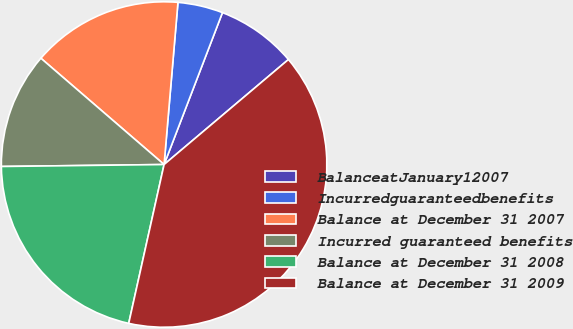Convert chart. <chart><loc_0><loc_0><loc_500><loc_500><pie_chart><fcel>BalanceatJanuary12007<fcel>Incurredguaranteedbenefits<fcel>Balance at December 31 2007<fcel>Incurred guaranteed benefits<fcel>Balance at December 31 2008<fcel>Balance at December 31 2009<nl><fcel>8.0%<fcel>4.48%<fcel>15.03%<fcel>11.52%<fcel>21.32%<fcel>39.65%<nl></chart> 